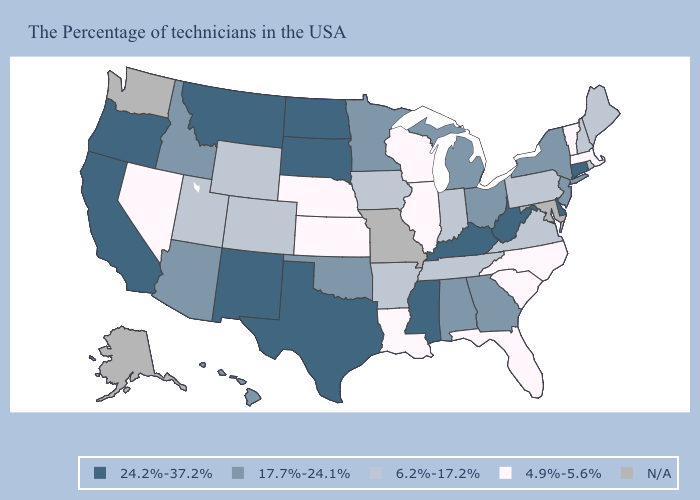What is the lowest value in the South?
Be succinct. 4.9%-5.6%. Name the states that have a value in the range N/A?
Concise answer only. Maryland, Missouri, Washington, Alaska. Name the states that have a value in the range 6.2%-17.2%?
Short answer required. Maine, Rhode Island, New Hampshire, Pennsylvania, Virginia, Indiana, Tennessee, Arkansas, Iowa, Wyoming, Colorado, Utah. Among the states that border New Hampshire , does Massachusetts have the lowest value?
Write a very short answer. Yes. What is the highest value in states that border Wisconsin?
Short answer required. 17.7%-24.1%. Does North Carolina have the lowest value in the South?
Give a very brief answer. Yes. Which states have the highest value in the USA?
Be succinct. Connecticut, Delaware, West Virginia, Kentucky, Mississippi, Texas, South Dakota, North Dakota, New Mexico, Montana, California, Oregon. Does North Carolina have the lowest value in the USA?
Be succinct. Yes. Name the states that have a value in the range N/A?
Concise answer only. Maryland, Missouri, Washington, Alaska. How many symbols are there in the legend?
Be succinct. 5. What is the lowest value in the USA?
Concise answer only. 4.9%-5.6%. Does Massachusetts have the lowest value in the Northeast?
Be succinct. Yes. What is the value of Missouri?
Write a very short answer. N/A. Which states have the lowest value in the USA?
Concise answer only. Massachusetts, Vermont, North Carolina, South Carolina, Florida, Wisconsin, Illinois, Louisiana, Kansas, Nebraska, Nevada. 